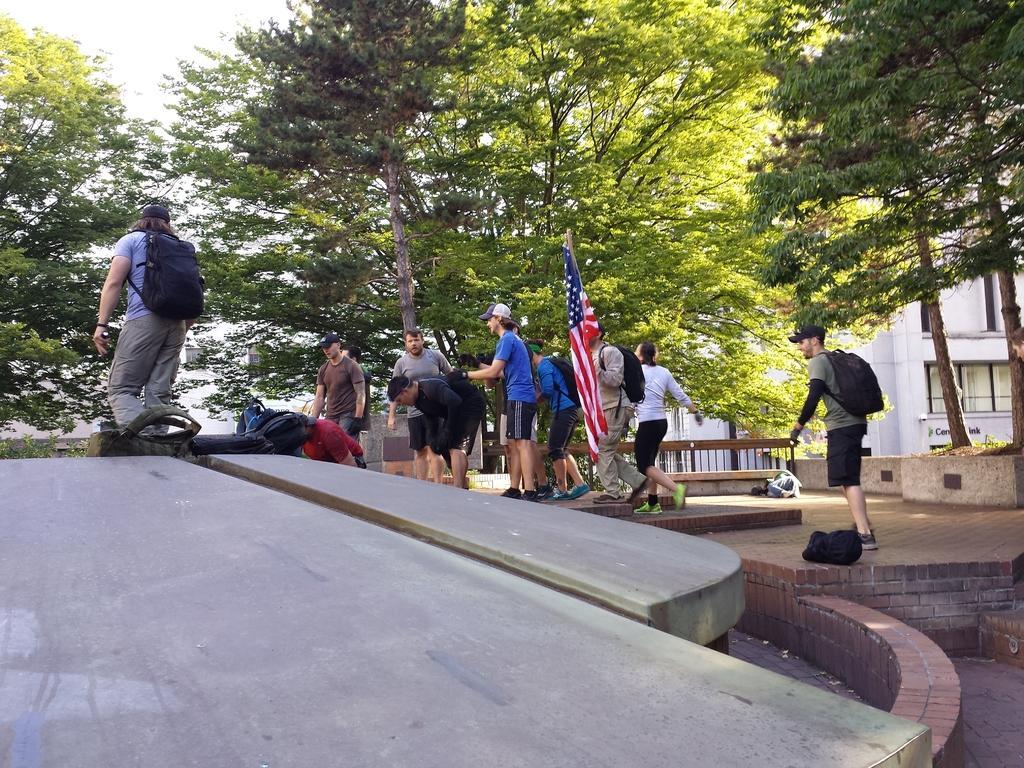Could you give a brief overview of what you see in this image? In this image there are a group of people who are standing and some of them are wearing bags, and in the center there is one pole and flag. And in the background there are some trees and houses, at the bottom there is a walkway. 